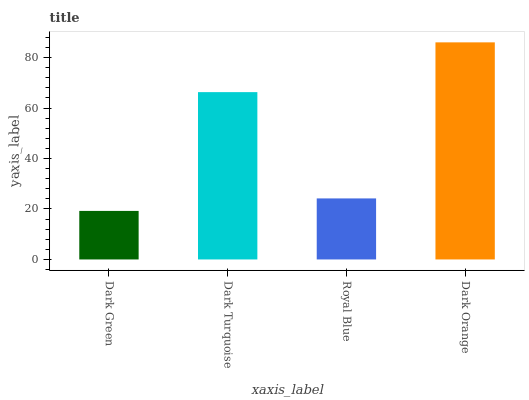Is Dark Green the minimum?
Answer yes or no. Yes. Is Dark Orange the maximum?
Answer yes or no. Yes. Is Dark Turquoise the minimum?
Answer yes or no. No. Is Dark Turquoise the maximum?
Answer yes or no. No. Is Dark Turquoise greater than Dark Green?
Answer yes or no. Yes. Is Dark Green less than Dark Turquoise?
Answer yes or no. Yes. Is Dark Green greater than Dark Turquoise?
Answer yes or no. No. Is Dark Turquoise less than Dark Green?
Answer yes or no. No. Is Dark Turquoise the high median?
Answer yes or no. Yes. Is Royal Blue the low median?
Answer yes or no. Yes. Is Dark Green the high median?
Answer yes or no. No. Is Dark Green the low median?
Answer yes or no. No. 